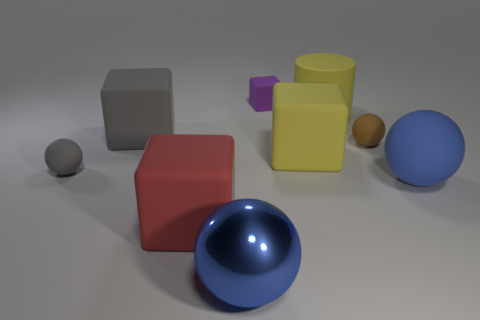What size is the gray matte object that is in front of the cube that is on the left side of the red rubber object?
Provide a short and direct response. Small. What is the material of the purple thing that is the same size as the brown object?
Offer a terse response. Rubber. Is there another object that has the same material as the large red thing?
Give a very brief answer. Yes. What color is the tiny rubber sphere that is on the left side of the gray matte thing behind the tiny sphere on the left side of the large red block?
Keep it short and to the point. Gray. Is the color of the small matte sphere right of the purple cube the same as the large rubber cylinder that is behind the large shiny object?
Give a very brief answer. No. Is there anything else that is the same color as the tiny block?
Make the answer very short. No. Is the number of gray blocks on the right side of the large blue rubber ball less than the number of big purple rubber objects?
Offer a very short reply. No. How many tiny matte things are there?
Your answer should be compact. 3. Do the tiny gray matte thing and the gray thing that is behind the gray sphere have the same shape?
Keep it short and to the point. No. Is the number of purple rubber objects left of the big shiny ball less than the number of yellow rubber cylinders to the left of the big cylinder?
Make the answer very short. No. 